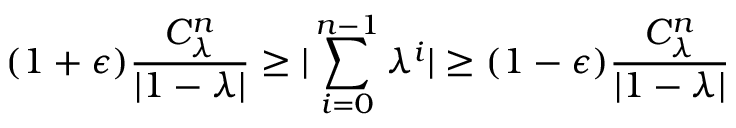Convert formula to latex. <formula><loc_0><loc_0><loc_500><loc_500>( 1 + \epsilon ) \frac { C _ { \lambda } ^ { n } } { | 1 - \lambda | } \geq | \sum _ { i = 0 } ^ { n - 1 } \lambda ^ { i } | \geq ( 1 - \epsilon ) \frac { C _ { \lambda } ^ { n } } { | 1 - \lambda | }</formula> 